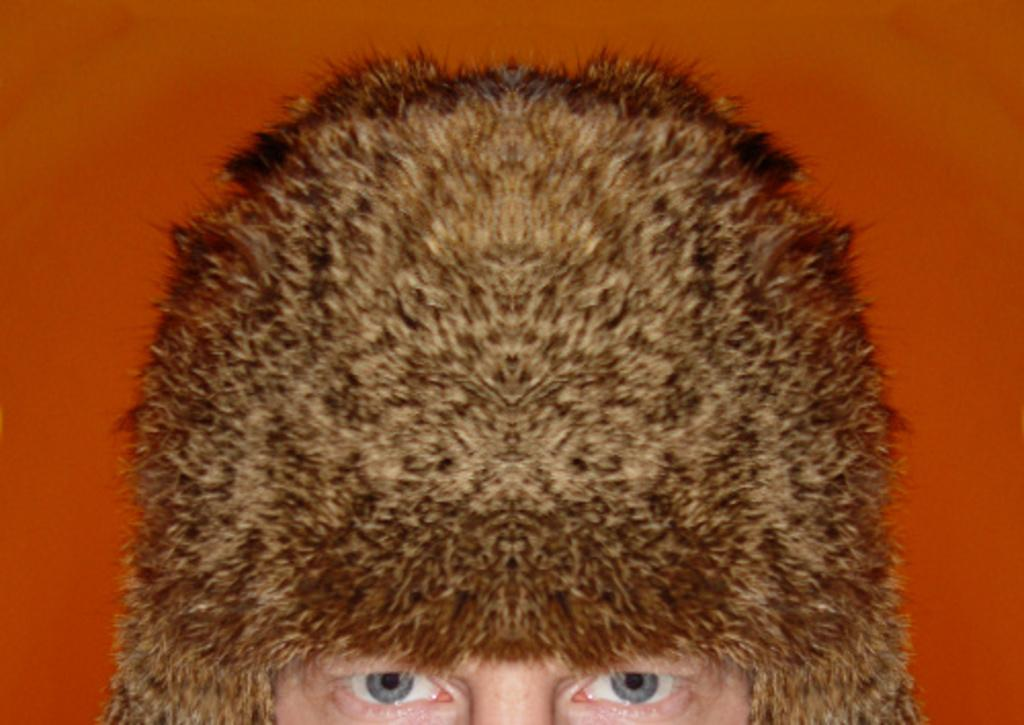Who is present in the image? There is a person in the image. What part of the person's face can be seen in the image? The person's eye is visible in the image. What type of clothing is the person wearing in the image? The person is wearing a cap in the image. What game is the person requesting to play in the image? There is no game or request present in the image; it only shows a person with a visible eye and a cap. 